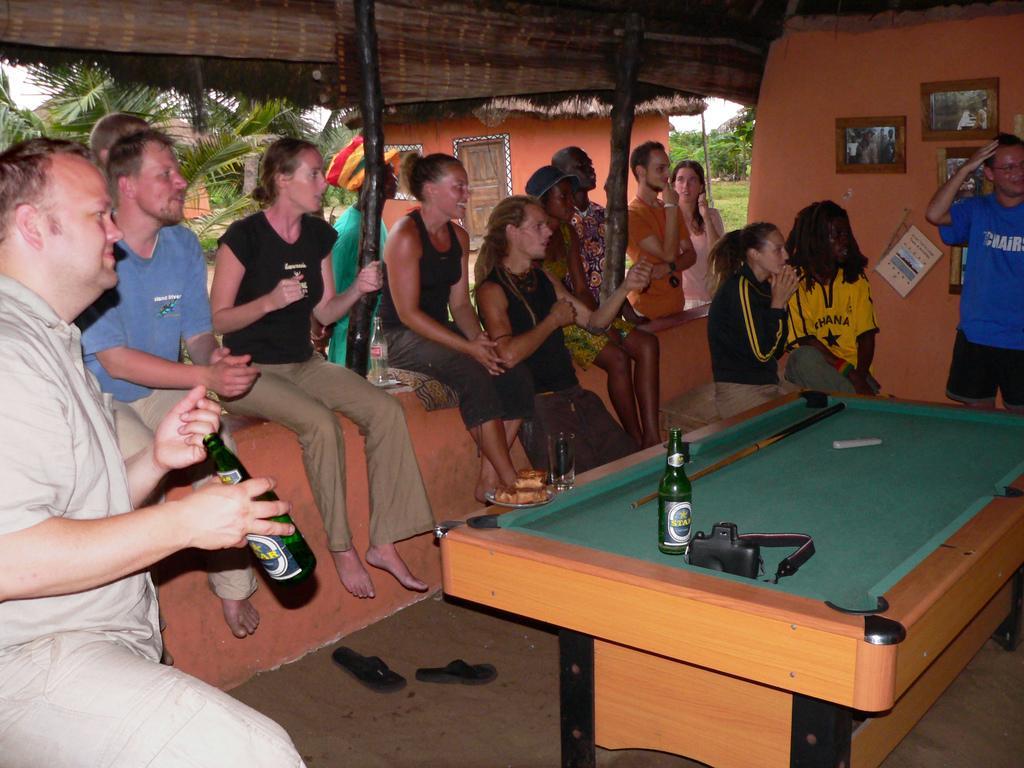In one or two sentences, can you explain what this image depicts? In this image we can see a group of people are sitting, and in front here is the table, and board and bottle and stick on it, and here is the wall and photo frames on it, and here are the trees, and here is the house. 